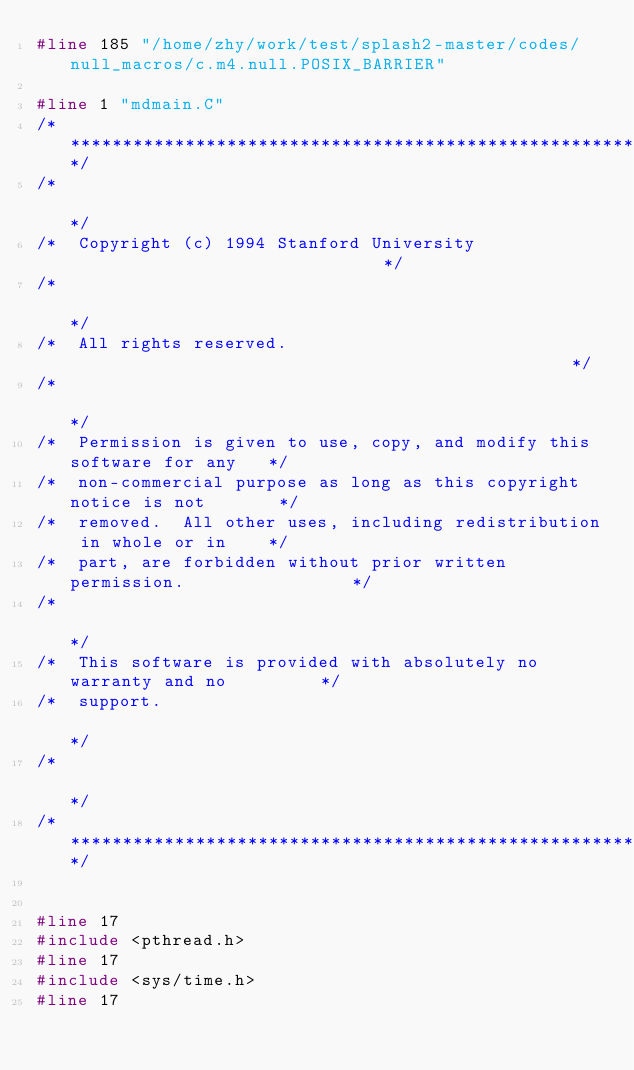<code> <loc_0><loc_0><loc_500><loc_500><_C_>#line 185 "/home/zhy/work/test/splash2-master/codes/null_macros/c.m4.null.POSIX_BARRIER"

#line 1 "mdmain.C"
/*************************************************************************/
/*                                                                       */
/*  Copyright (c) 1994 Stanford University                               */
/*                                                                       */
/*  All rights reserved.                                                 */
/*                                                                       */
/*  Permission is given to use, copy, and modify this software for any   */
/*  non-commercial purpose as long as this copyright notice is not       */
/*  removed.  All other uses, including redistribution in whole or in    */
/*  part, are forbidden without prior written permission.                */
/*                                                                       */
/*  This software is provided with absolutely no warranty and no         */
/*  support.                                                             */
/*                                                                       */
/*************************************************************************/


#line 17
#include <pthread.h>
#line 17
#include <sys/time.h>
#line 17</code> 